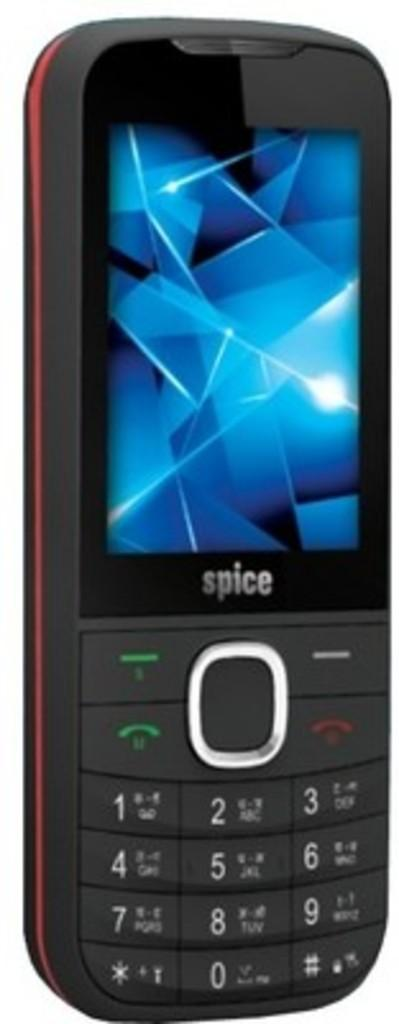Provide a one-sentence caption for the provided image. A cell phone with a number that has the digits 0 through 9. 